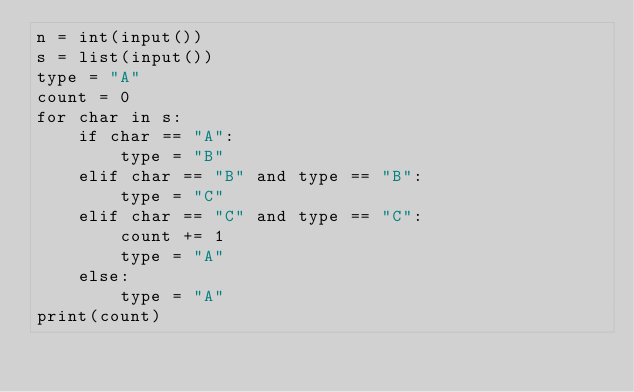Convert code to text. <code><loc_0><loc_0><loc_500><loc_500><_Python_>n = int(input())
s = list(input())
type = "A"
count = 0
for char in s:
    if char == "A":
        type = "B"
    elif char == "B" and type == "B":
        type = "C"
    elif char == "C" and type == "C":
        count += 1
        type = "A"
    else:
        type = "A"
print(count)</code> 